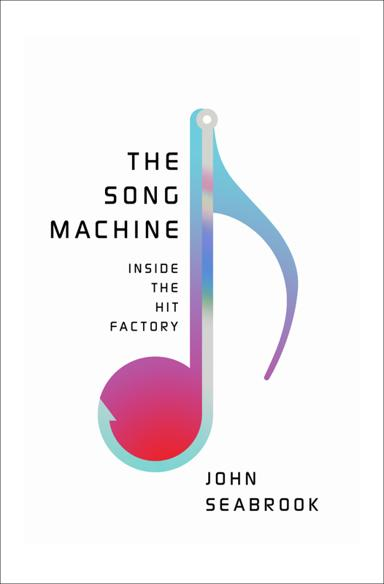What impact does the music production process described in this book have on global pop culture? The music production processes explored in "The Song Machine" have profound impacts on global pop culture. It reveals how a handful of producers and songwriters can determine the trends and sounds that dominate the charts, influencing what millions of people listen to daily. The book highlights how this system not only shapes musical preferences but also affects cultural identities and norms, making it an essential component of global entertainment. How does the public generally react to learning about these behind-the-scenes details of the music industry? Public reactions to the behind-the-scenes insights provided by books like 'The Song Machine' are mixed. While some fans appreciate the intricate craftsmanship and the expertise involved, others may feel disillusioned by the commercial strategies that so heavily influence what is presented as popular music. This revelation can alter perceptions of authenticity and artistry in music, leading to broader discussions about what constitutes 'true' musical talent. 